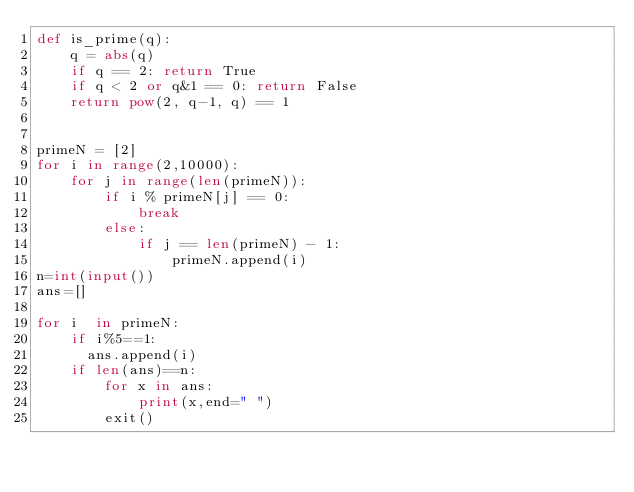Convert code to text. <code><loc_0><loc_0><loc_500><loc_500><_Python_>def is_prime(q):
    q = abs(q)
    if q == 2: return True
    if q < 2 or q&1 == 0: return False
    return pow(2, q-1, q) == 1


primeN = [2]
for i in range(2,10000):
    for j in range(len(primeN)):
        if i % primeN[j] == 0:
            break
        else:
            if j == len(primeN) - 1:
                primeN.append(i)
n=int(input())
ans=[]

for i  in primeN:
    if i%5==1:
      ans.append(i)
    if len(ans)==n:
        for x in ans:
            print(x,end=" ")
        exit()
    
</code> 